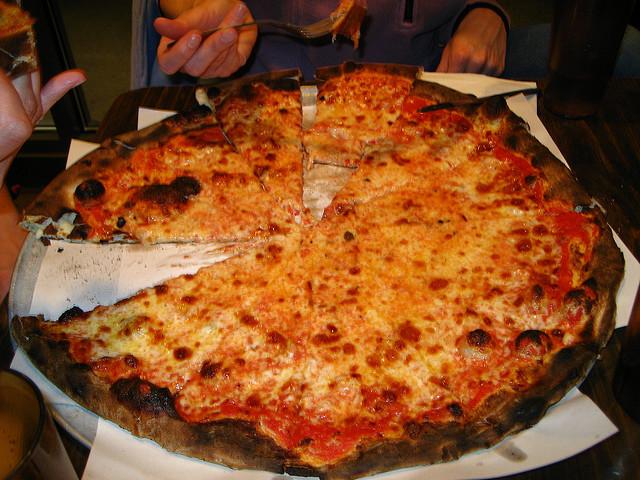What is in the picture?
Give a very brief answer. Pizza. What type of pizza is it?
Concise answer only. Cheese. Has anyone eaten the pizza?
Concise answer only. Yes. Is this pizza vegetarian?
Answer briefly. Yes. What topping is on the pizza on the right?
Write a very short answer. Cheese. How many pieces of pizza are missing?
Be succinct. 1. What food is in the dish they are holding?
Short answer required. Pizza. 